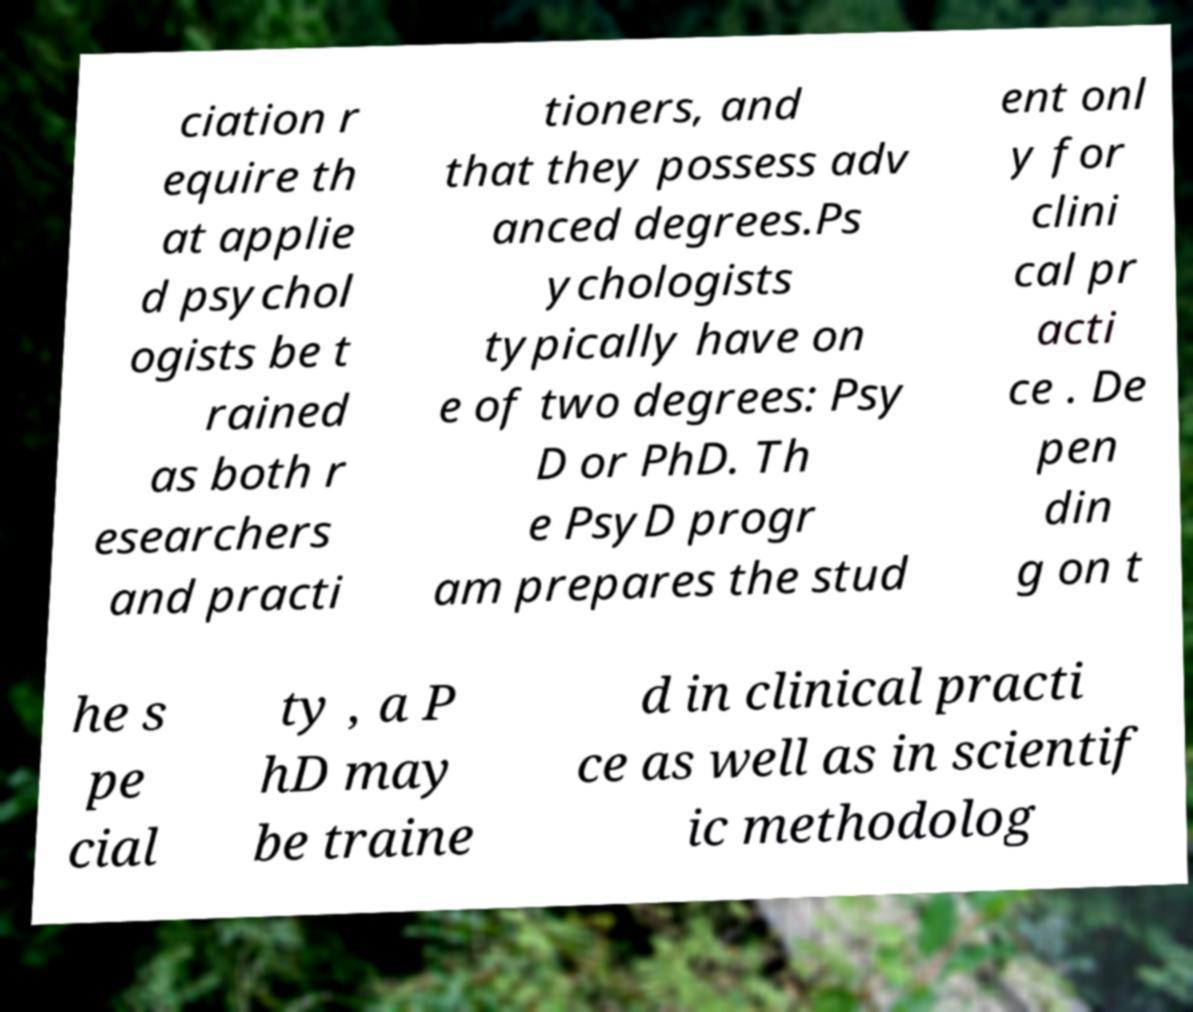There's text embedded in this image that I need extracted. Can you transcribe it verbatim? ciation r equire th at applie d psychol ogists be t rained as both r esearchers and practi tioners, and that they possess adv anced degrees.Ps ychologists typically have on e of two degrees: Psy D or PhD. Th e PsyD progr am prepares the stud ent onl y for clini cal pr acti ce . De pen din g on t he s pe cial ty , a P hD may be traine d in clinical practi ce as well as in scientif ic methodolog 